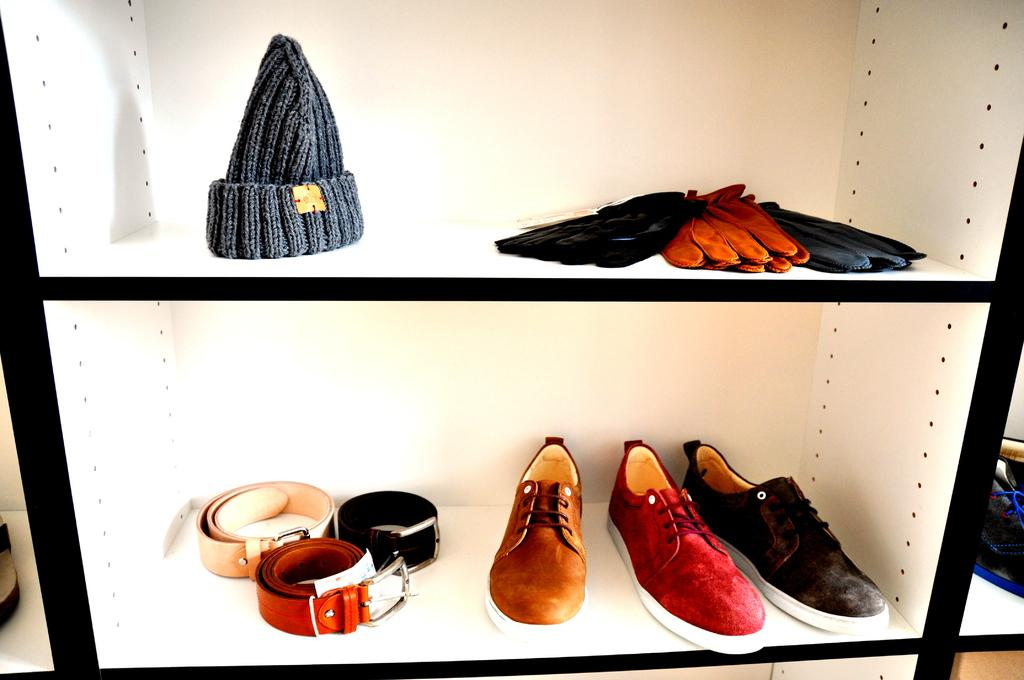What is the main object in the image? There is a rack in the image. What items can be found on the rack? The rack contains shoes, belts, gloves, and a cap. What is the color scheme of the rack? The rack is in white and black color. What type of music can be heard coming from the cellar in the image? There is no cellar or music present in the image; it only features a rack with various items. Can you see a pail on the rack in the image? No, there is no pail on the rack in the image. 